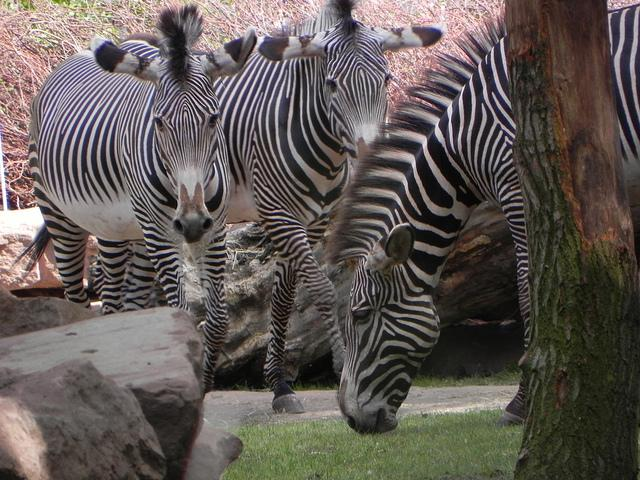What animals are most similar to these? horse 